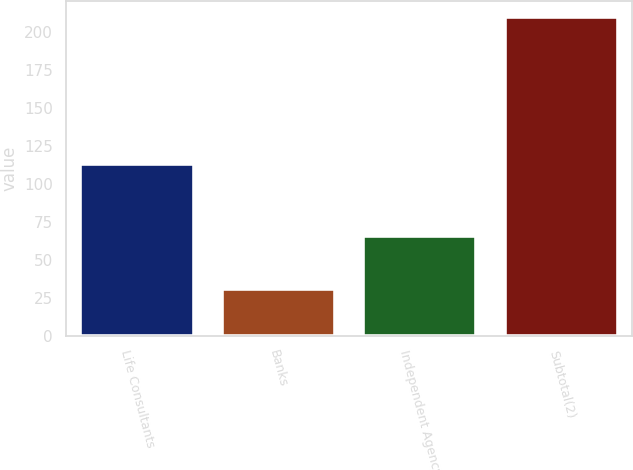Convert chart to OTSL. <chart><loc_0><loc_0><loc_500><loc_500><bar_chart><fcel>Life Consultants<fcel>Banks<fcel>Independent Agency<fcel>Subtotal(2)<nl><fcel>113<fcel>31<fcel>66<fcel>210<nl></chart> 